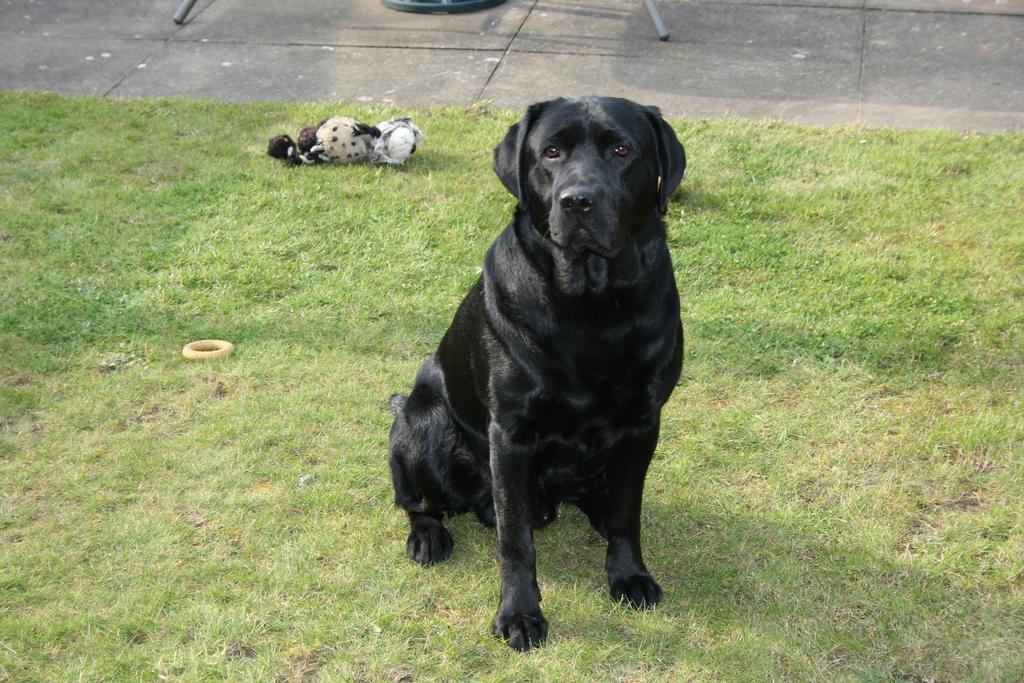Please provide a concise description of this image. In this picture we can see the grass, black dog and in the background we can see some objects. 